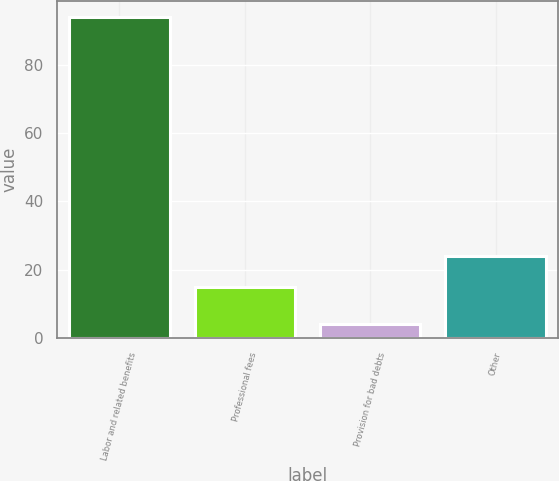Convert chart to OTSL. <chart><loc_0><loc_0><loc_500><loc_500><bar_chart><fcel>Labor and related benefits<fcel>Professional fees<fcel>Provision for bad debts<fcel>Other<nl><fcel>94<fcel>15<fcel>4<fcel>24<nl></chart> 